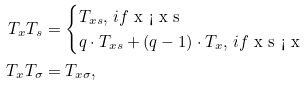<formula> <loc_0><loc_0><loc_500><loc_500>T _ { x } T _ { s } & = \begin{cases} T _ { x s } , \, i f $ x < x s $ \\ q \cdot T _ { x s } + ( q - 1 ) \cdot T _ { x } , \, i f $ x s < x $ \end{cases} \\ T _ { x } T _ { \sigma } & = T _ { x \sigma } ,</formula> 